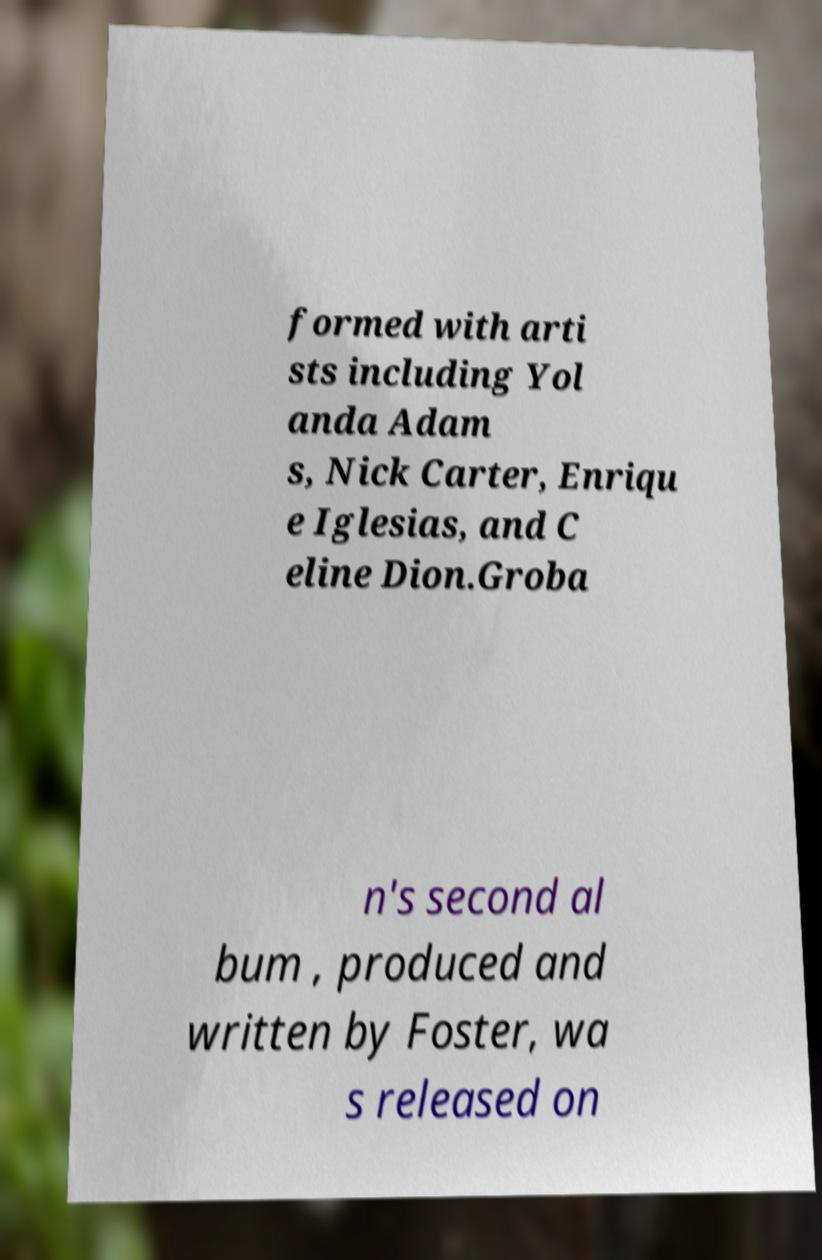What messages or text are displayed in this image? I need them in a readable, typed format. formed with arti sts including Yol anda Adam s, Nick Carter, Enriqu e Iglesias, and C eline Dion.Groba n's second al bum , produced and written by Foster, wa s released on 